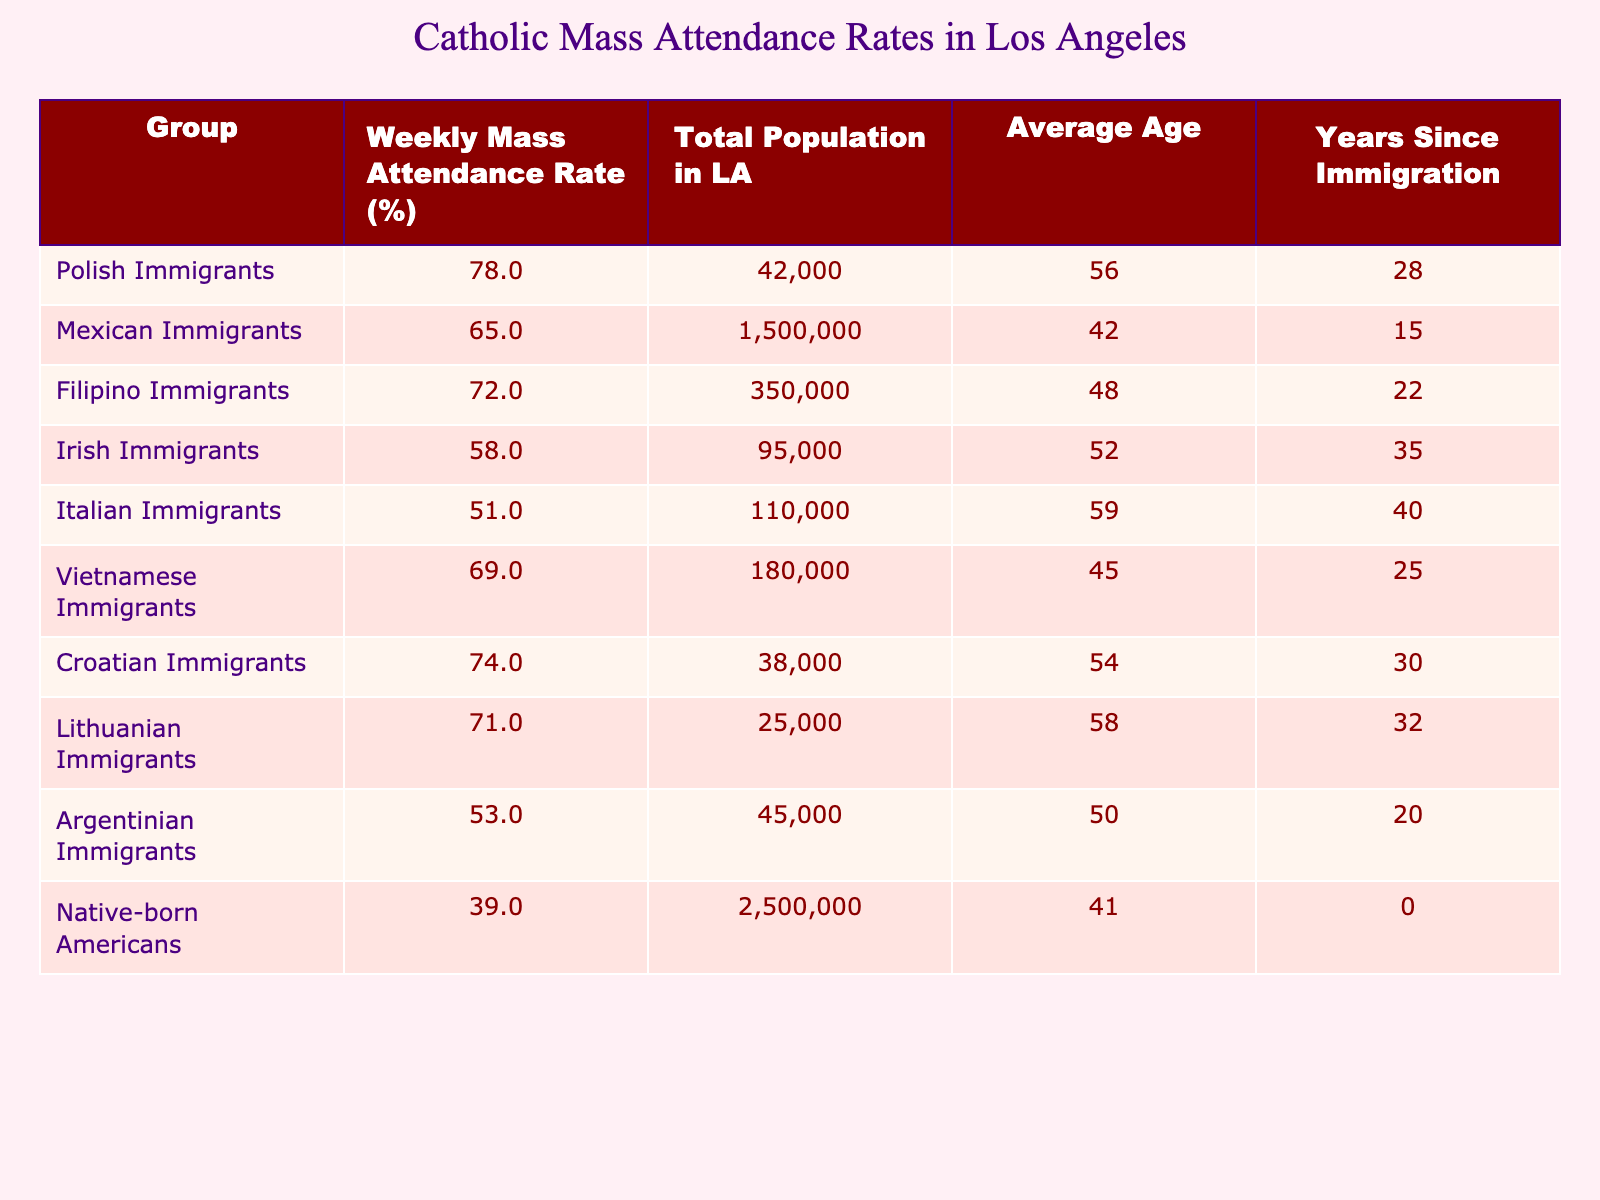What is the weekly mass attendance rate for Polish immigrants? According to the table, the weekly mass attendance rate for Polish immigrants is listed directly under the "Weekly Mass Attendance Rate (%)" column, showing a rate of 78%.
Answer: 78% Which immigrant group has the highest weekly mass attendance rate? The table shows the weekly mass attendance rates for various groups. By comparing these rates, Polish immigrants at 78% have the highest rate among all groups.
Answer: Polish Immigrants What is the total population of Mexican immigrants in Los Angeles? The total population for Mexican immigrants is provided in the "Total Population in LA" column, which indicates a population of 1,500,000.
Answer: 1,500,000 What is the average age of Irish immigrants? The average age of Irish immigrants is shown in the "Average Age" column, listing it as 52 years.
Answer: 52 How many more percentage points do Polish immigrants attend mass compared to Native-born Americans? Polish immigrants have a mass attendance rate of 78%, while Native-born Americans have a rate of 39%. The difference is 78 - 39 = 39 percentage points.
Answer: 39 Which group has the lowest average age among immigrants listed? The "Average Age" column shows the ages of each group. Filipino immigrants at 48 years have the lowest average age among the immigrant groups.
Answer: Filipino Immigrants Is the mass attendance rate of Vietnamese immigrants higher than that of Lithuanian immigrants? Vietnamese immigrants have a rate of 69%, and Lithuanian immigrants have a rate of 71%. Since 69% is less than 71%, the statement is false.
Answer: No What is the combined total population of Polish and Croatian immigrants? The table indicates that Polish immigrants have a total population of 42,000 and Croatian immigrants have 38,000. Adding these gives 42,000 + 38,000 = 80,000.
Answer: 80,000 Which immigrant group has the longest average years since immigration? Reviewing the "Years Since Immigration" column, Italian immigrants have the longest with 40 years since immigration.
Answer: Italian Immigrants What is the average weekly mass attendance rate for the listed immigrant groups? To find the average, sum the rates of all groups and divide by the number of groups: (78 + 65 + 72 + 58 + 51 + 69 + 74 + 71 + 53 + 39) =  78/10 = 62.3%.
Answer: 62.3% 